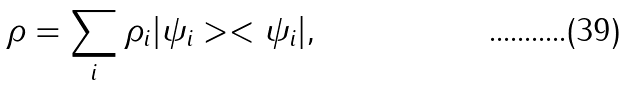Convert formula to latex. <formula><loc_0><loc_0><loc_500><loc_500>\rho = \sum _ { i } \rho _ { i } | \psi _ { i } > < \psi _ { i } | ,</formula> 